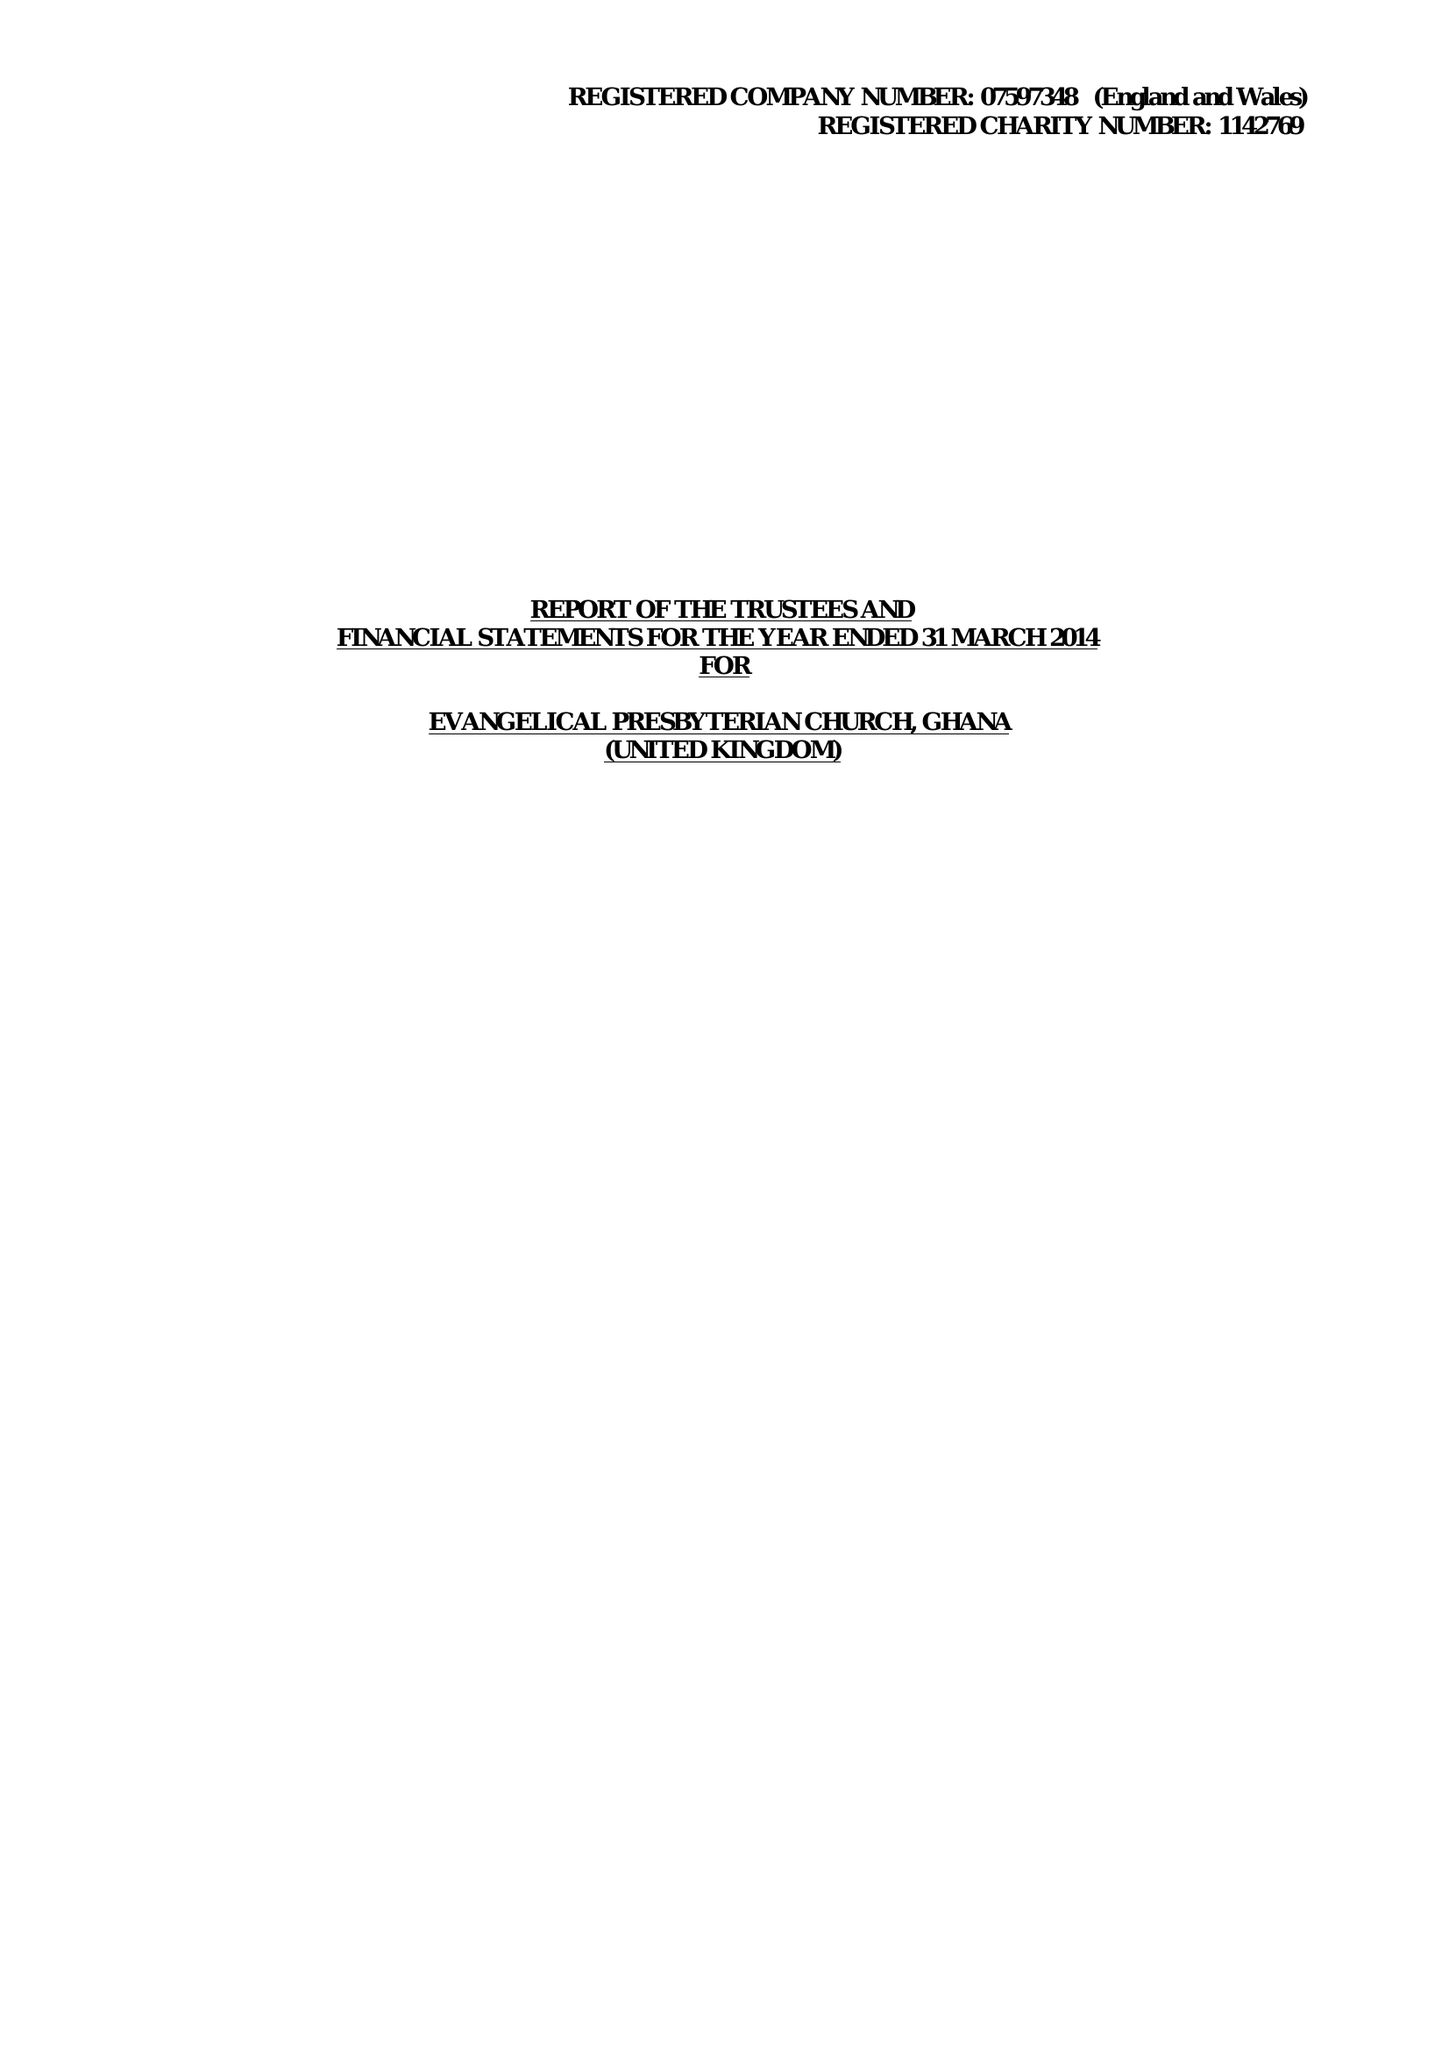What is the value for the charity_name?
Answer the question using a single word or phrase. Evangelical Presbyterian Church, Ghana (United Kingdom) 